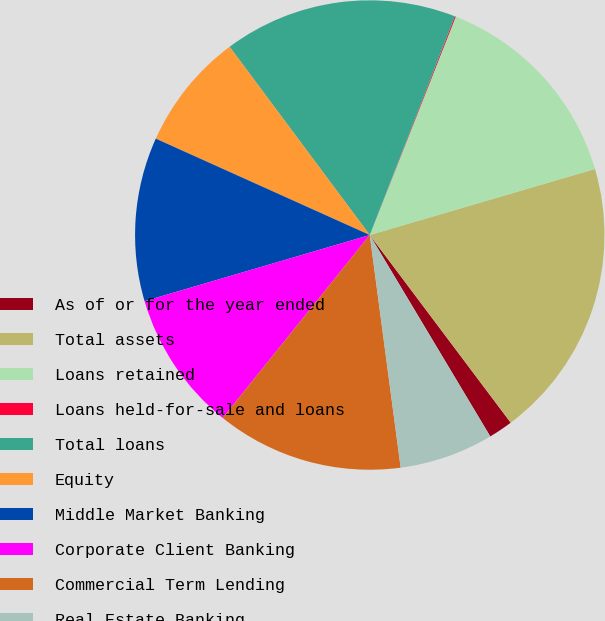<chart> <loc_0><loc_0><loc_500><loc_500><pie_chart><fcel>As of or for the year ended<fcel>Total assets<fcel>Loans retained<fcel>Loans held-for-sale and loans<fcel>Total loans<fcel>Equity<fcel>Middle Market Banking<fcel>Corporate Client Banking<fcel>Commercial Term Lending<fcel>Real Estate Banking<nl><fcel>1.67%<fcel>19.29%<fcel>14.49%<fcel>0.07%<fcel>16.09%<fcel>8.08%<fcel>11.28%<fcel>9.68%<fcel>12.88%<fcel>6.48%<nl></chart> 